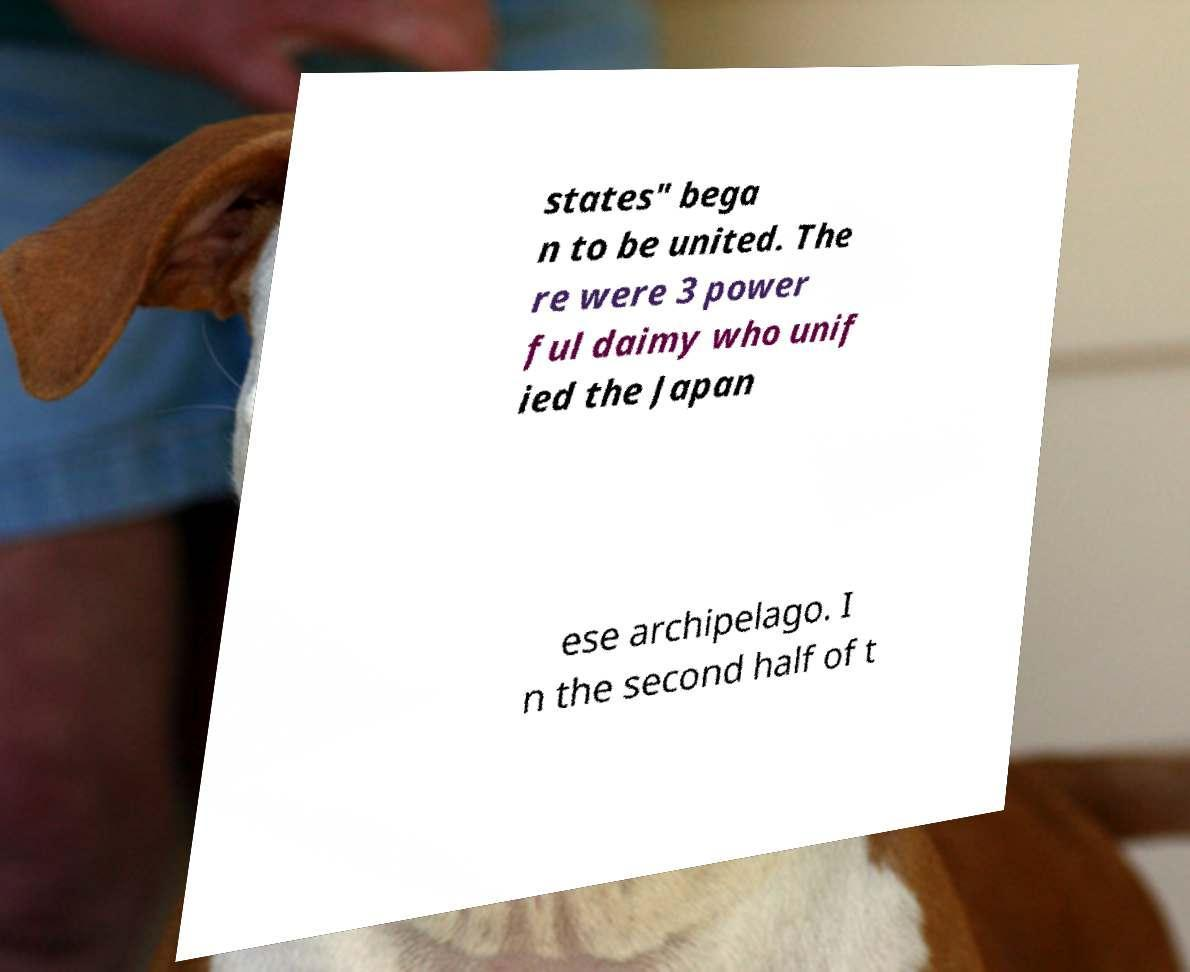There's text embedded in this image that I need extracted. Can you transcribe it verbatim? states" bega n to be united. The re were 3 power ful daimy who unif ied the Japan ese archipelago. I n the second half of t 